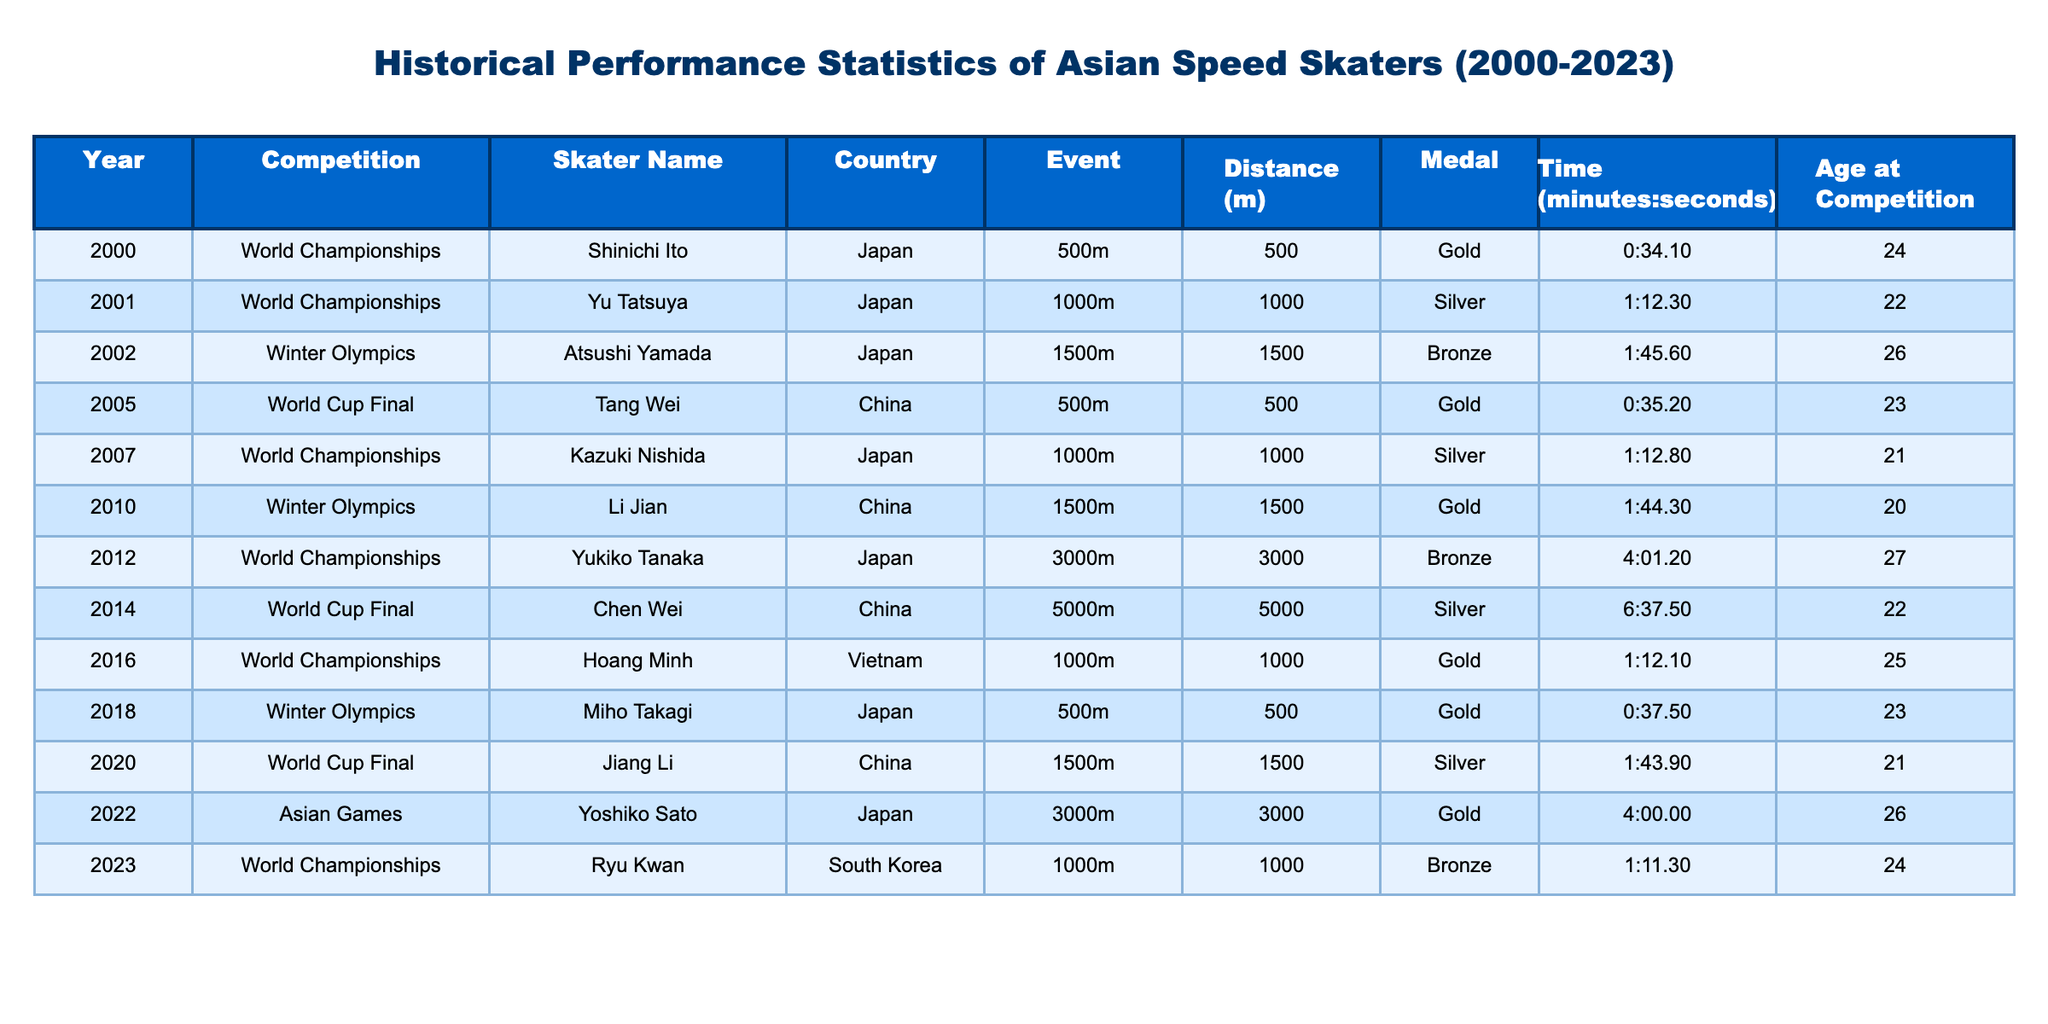What is the fastest recorded time for the 500m event by an Asian skater? The table shows two entries for the 500m event: Shinichi Ito with a time of 0:34.10 in 2000 and Miho Takagi with a time of 0:37.50 in 2018. Since 0:34.10 is faster than 0:37.50, the fastest time is 0:34.10.
Answer: 0:34.10 How many gold medals were won by skaters from Japan? The table lists the following gold medal wins for Japan: Shinichi Ito (2000), Miho Takagi (2018), Atsushi Yamada (2002), Yukiko Tanaka (2012), and Yoshiko Sato (2022), which totals to five.
Answer: 5 Was there any Asian skater that won a medal in the 3000m event? The data includes one entry for the 3000m event: Yukiko Tanaka won a bronze in 2012, so the answer is yes.
Answer: Yes What is the average age of skaters winning medals at the World Championships? The table lists the following ages for medals won in the World Championships: 24 (2000), 21 (2007), 25 (2016), and 24 (2023). The average is calculated as (24 + 21 + 25 + 24) / 4 = 23.5.
Answer: 23.5 Which country had the highest number of gold medals based on this data? The gold medals are distributed as follows: Japan has 4 (Shinichi Ito, Atsushi Yamada, Miho Takagi, Yukiko Tanaka, and Yoshiko Sato), while China has 2 (Tang Wei and Li Jian). Japan has the highest number of gold medals.
Answer: Japan 